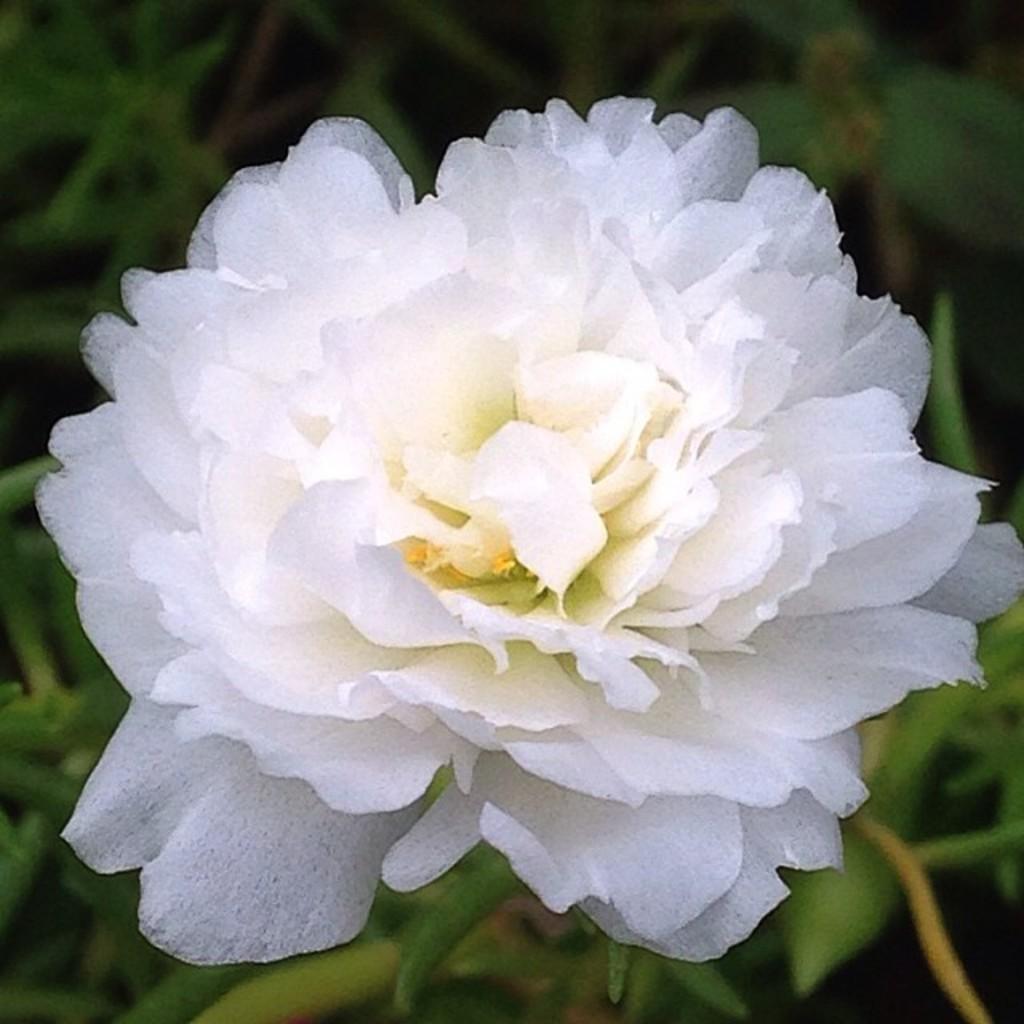How would you summarize this image in a sentence or two? This is a zoomed in picture. In the foreground there is a white color flower and the green leaves of a plant. In the background we can see the plants. 